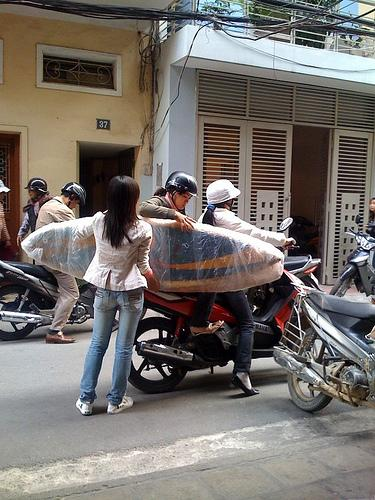What is the cellophane wrapping applied over top of? Please explain your reasoning. surfboard. It is a means of water transportation. 